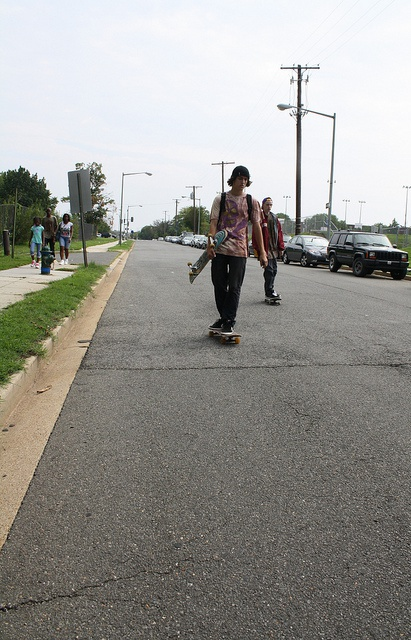Describe the objects in this image and their specific colors. I can see people in white, black, gray, and maroon tones, car in white, black, gray, darkgray, and lightgray tones, people in white, black, maroon, gray, and darkgray tones, car in white, black, lightgray, darkgray, and gray tones, and people in white, black, teal, and gray tones in this image. 